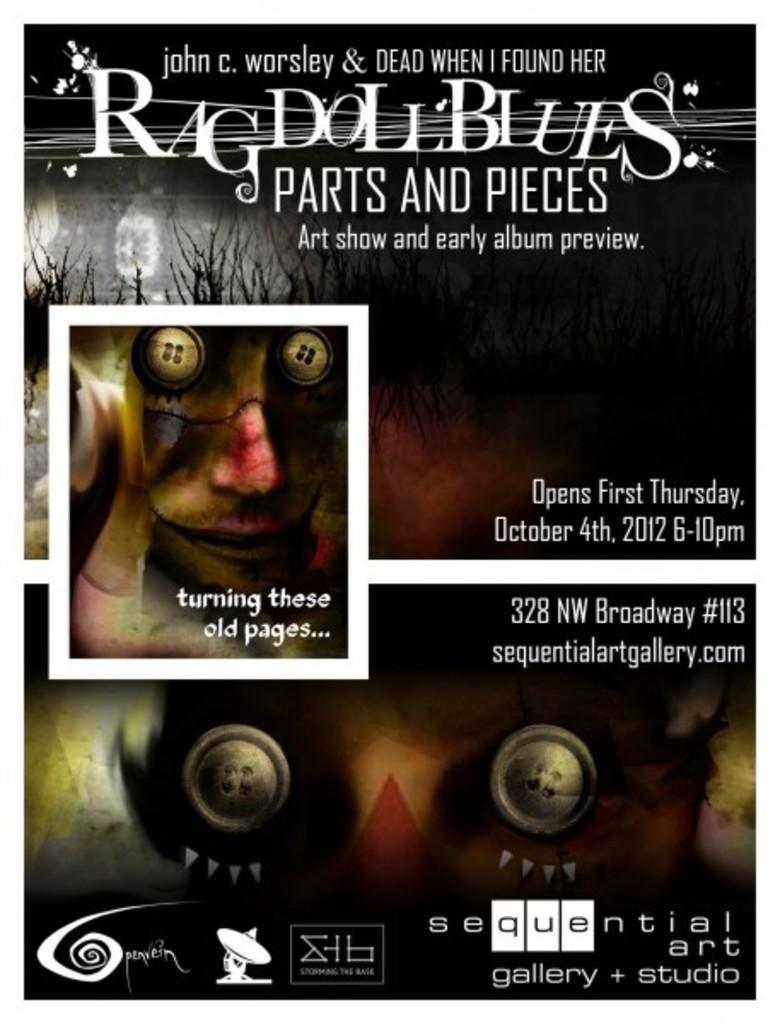Can you describe this image briefly? In this picture we can see a black color object seems to be a poster on which we can see the text, numbers and a picture of a person and pictures of some other objects. 